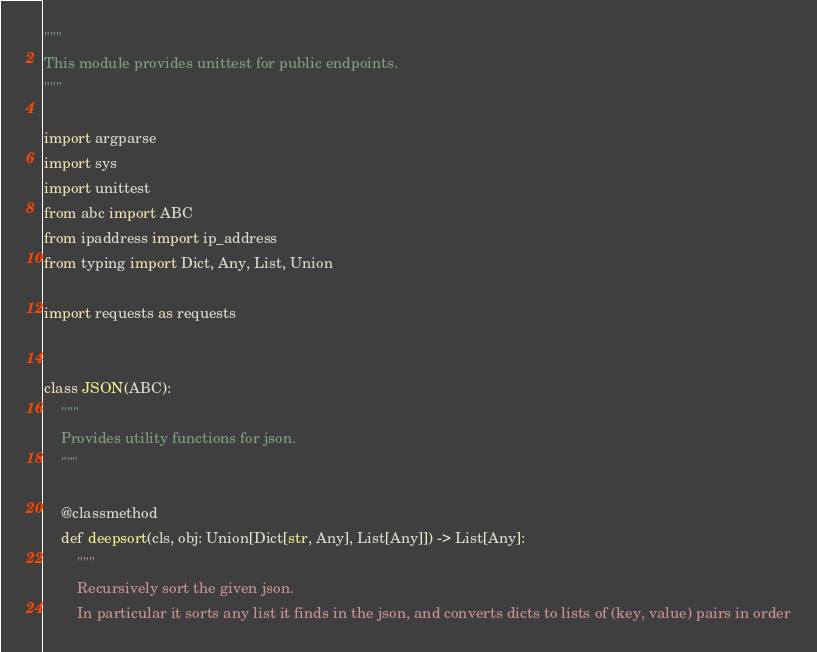Convert code to text. <code><loc_0><loc_0><loc_500><loc_500><_Python_>"""
This module provides unittest for public endpoints.
"""

import argparse
import sys
import unittest
from abc import ABC
from ipaddress import ip_address
from typing import Dict, Any, List, Union

import requests as requests


class JSON(ABC):
    """
    Provides utility functions for json.
    """

    @classmethod
    def deepsort(cls, obj: Union[Dict[str, Any], List[Any]]) -> List[Any]:
        """
        Recursively sort the given json.
        In particular it sorts any list it finds in the json, and converts dicts to lists of (key, value) pairs in order</code> 